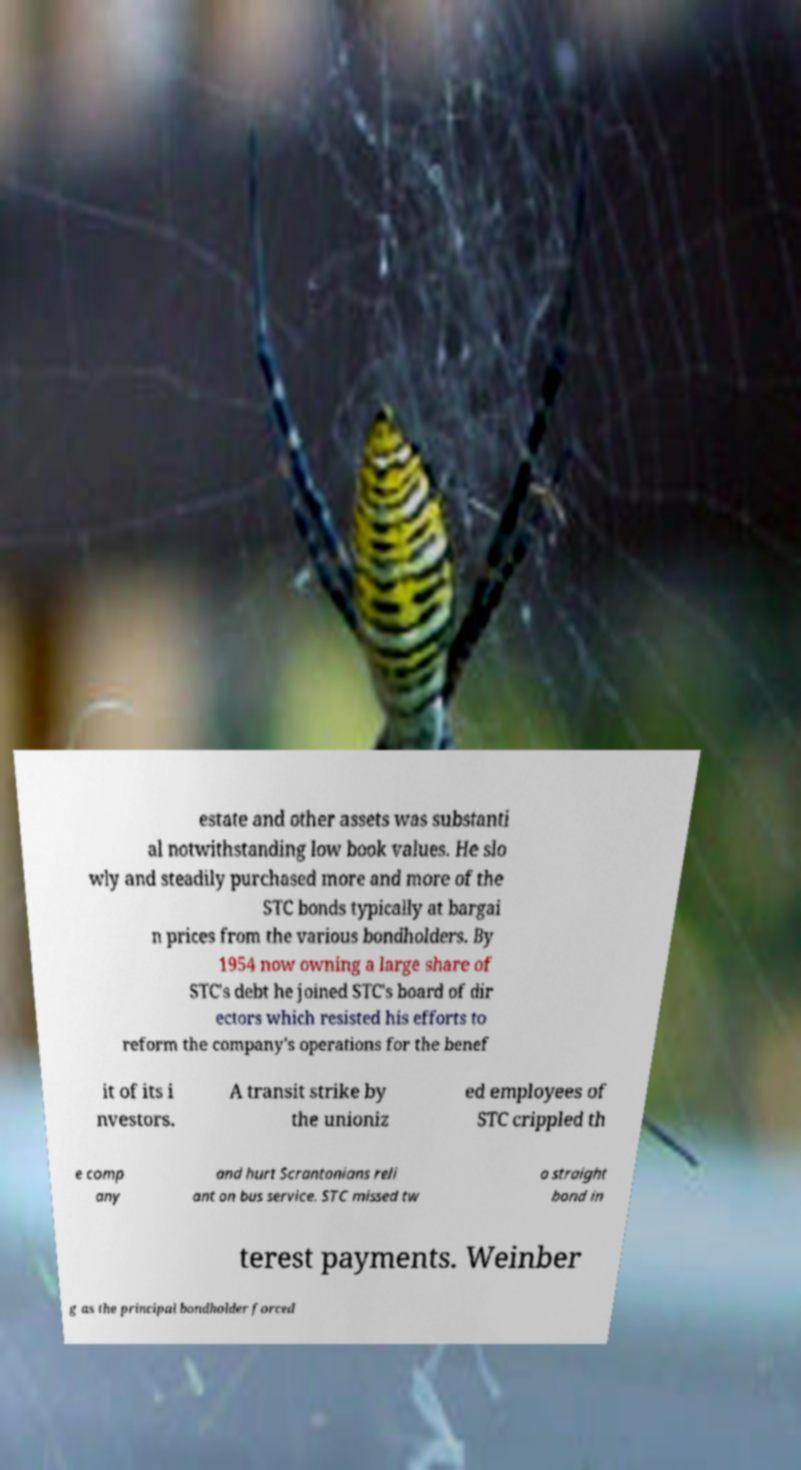Could you assist in decoding the text presented in this image and type it out clearly? estate and other assets was substanti al notwithstanding low book values. He slo wly and steadily purchased more and more of the STC bonds typically at bargai n prices from the various bondholders. By 1954 now owning a large share of STC's debt he joined STC's board of dir ectors which resisted his efforts to reform the company's operations for the benef it of its i nvestors. A transit strike by the unioniz ed employees of STC crippled th e comp any and hurt Scrantonians reli ant on bus service. STC missed tw o straight bond in terest payments. Weinber g as the principal bondholder forced 